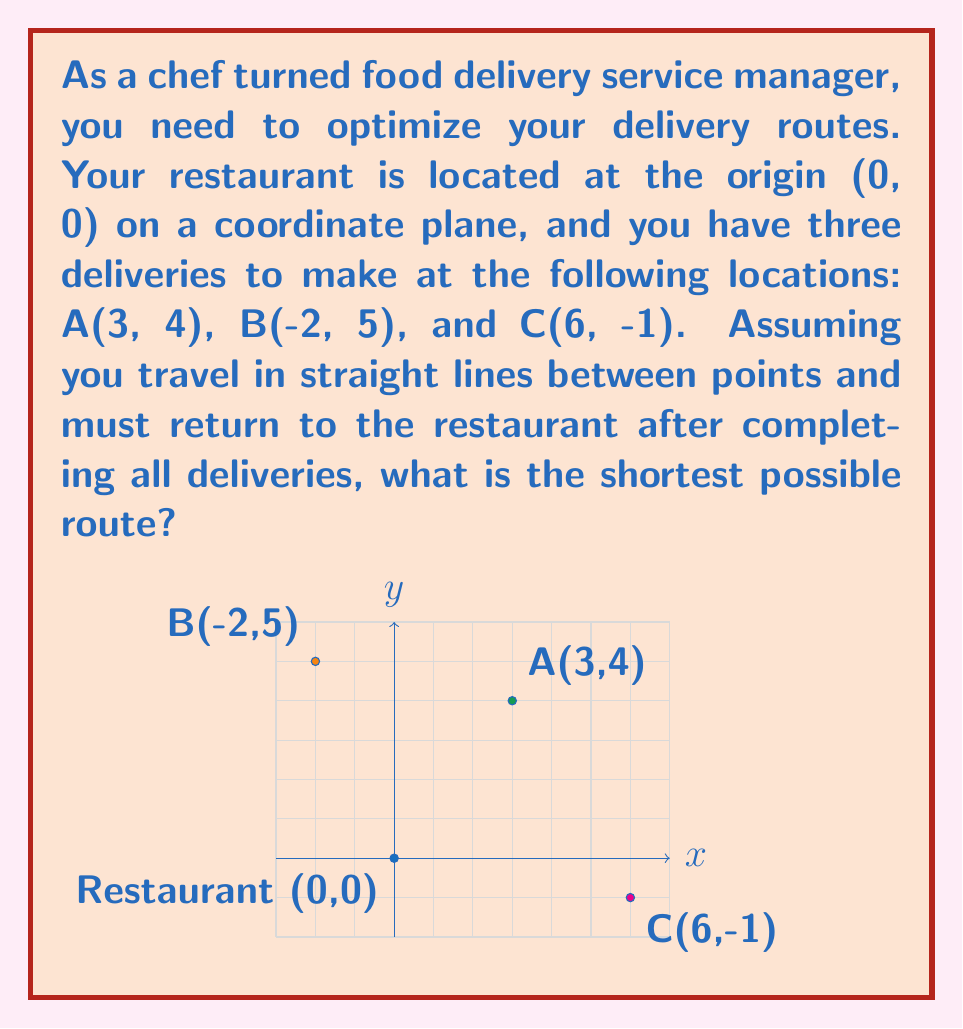Show me your answer to this math problem. To find the shortest route, we need to calculate the distances between all points and determine the optimal order. Let's approach this step-by-step:

1) First, calculate the distances between all points using the distance formula:
   $d = \sqrt{(x_2-x_1)^2 + (y_2-y_1)^2}$

   Restaurant to A: $\sqrt{(3-0)^2 + (4-0)^2} = 5$
   Restaurant to B: $\sqrt{(-2-0)^2 + (5-0)^2} = \sqrt{29}$
   Restaurant to C: $\sqrt{(6-0)^2 + (-1-0)^2} = \sqrt{37}$
   A to B: $\sqrt{(-2-3)^2 + (5-4)^2} = \sqrt{26}$
   A to C: $\sqrt{(6-3)^2 + (-1-4)^2} = \sqrt{34}$
   B to C: $\sqrt{(6-(-2))^2 + (-1-5)^2} = \sqrt{100} = 10$

2) Now, we need to consider all possible routes:
   Route 1: Restaurant → A → B → C → Restaurant
   Route 2: Restaurant → A → C → B → Restaurant
   Route 3: Restaurant → B → A → C → Restaurant
   Route 4: Restaurant → B → C → A → Restaurant
   Route 5: Restaurant → C → A → B → Restaurant
   Route 6: Restaurant → C → B → A → Restaurant

3) Calculate the total distance for each route:
   Route 1: $5 + \sqrt{26} + 10 + \sqrt{37} \approx 23.65$
   Route 2: $5 + \sqrt{34} + 10 + \sqrt{29} \approx 24.39$
   Route 3: $\sqrt{29} + \sqrt{26} + \sqrt{34} + \sqrt{37} \approx 23.36$
   Route 4: $\sqrt{29} + 10 + \sqrt{34} + 5 \approx 24.76$
   Route 5: $\sqrt{37} + \sqrt{34} + \sqrt{26} + \sqrt{29} \approx 23.36$
   Route 6: $\sqrt{37} + 10 + \sqrt{26} + 5 \approx 24.10$

4) The shortest route is either Route 3 or Route 5, both with a total distance of approximately 23.36 units.
Answer: Restaurant → B → A → C → Restaurant (or Restaurant → C → A → B → Restaurant), with a total distance of $\sqrt{29} + \sqrt{26} + \sqrt{34} + \sqrt{37} \approx 23.36$ units. 